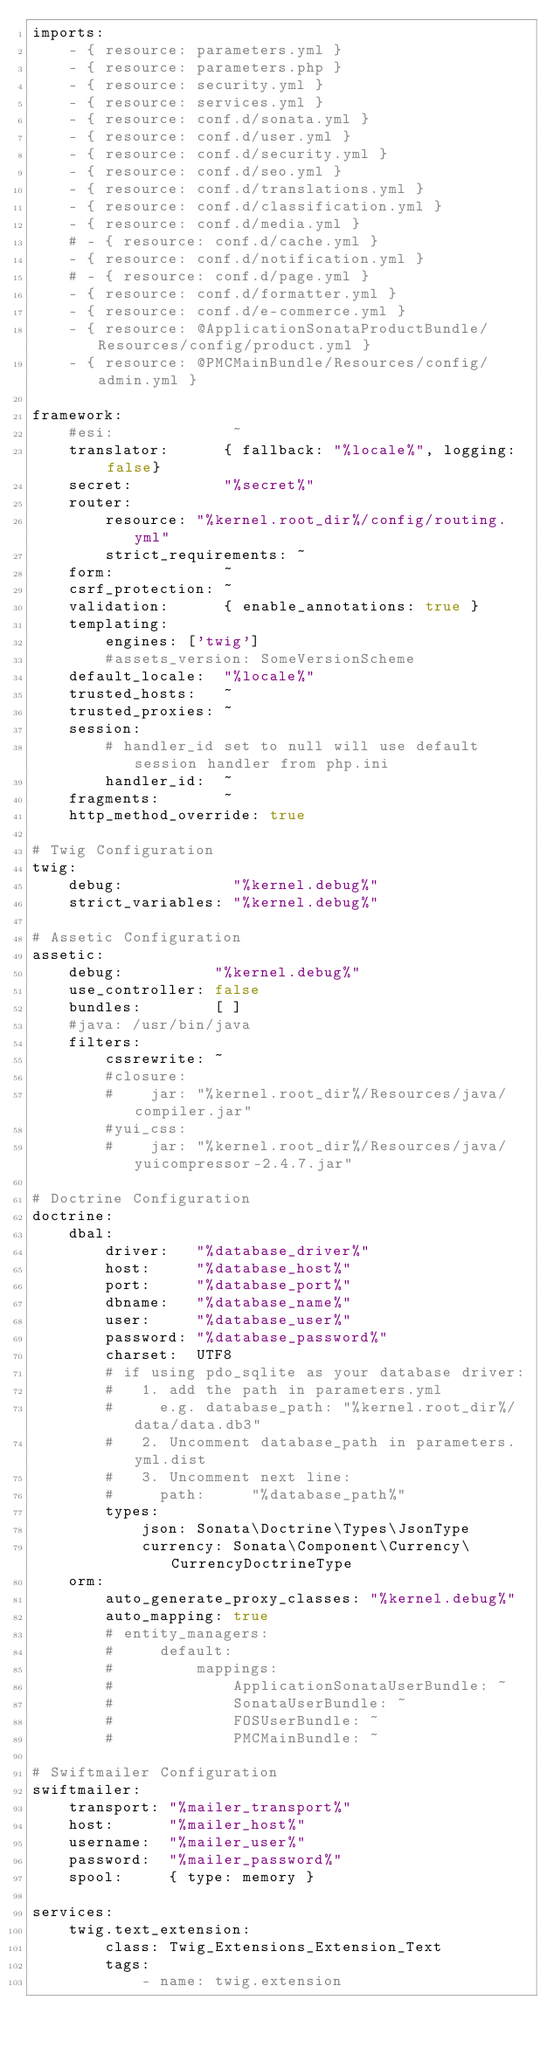Convert code to text. <code><loc_0><loc_0><loc_500><loc_500><_YAML_>imports:
    - { resource: parameters.yml }
    - { resource: parameters.php }
    - { resource: security.yml }
    - { resource: services.yml }
    - { resource: conf.d/sonata.yml }
    - { resource: conf.d/user.yml }
    - { resource: conf.d/security.yml }
    - { resource: conf.d/seo.yml }
    - { resource: conf.d/translations.yml }
    - { resource: conf.d/classification.yml }
    - { resource: conf.d/media.yml }
    # - { resource: conf.d/cache.yml }
    - { resource: conf.d/notification.yml }
    # - { resource: conf.d/page.yml }
    - { resource: conf.d/formatter.yml }
    - { resource: conf.d/e-commerce.yml }
    - { resource: @ApplicationSonataProductBundle/Resources/config/product.yml }
    - { resource: @PMCMainBundle/Resources/config/admin.yml }

framework:
    #esi:             ~
    translator:      { fallback: "%locale%", logging:  false}
    secret:          "%secret%"
    router:
        resource: "%kernel.root_dir%/config/routing.yml"
        strict_requirements: ~
    form:            ~
    csrf_protection: ~
    validation:      { enable_annotations: true }
    templating:
        engines: ['twig']
        #assets_version: SomeVersionScheme
    default_locale:  "%locale%"
    trusted_hosts:   ~
    trusted_proxies: ~
    session:
        # handler_id set to null will use default session handler from php.ini
        handler_id:  ~
    fragments:       ~
    http_method_override: true

# Twig Configuration
twig:
    debug:            "%kernel.debug%"
    strict_variables: "%kernel.debug%"

# Assetic Configuration
assetic:
    debug:          "%kernel.debug%"
    use_controller: false
    bundles:        [ ]
    #java: /usr/bin/java
    filters:
        cssrewrite: ~
        #closure:
        #    jar: "%kernel.root_dir%/Resources/java/compiler.jar"
        #yui_css:
        #    jar: "%kernel.root_dir%/Resources/java/yuicompressor-2.4.7.jar"

# Doctrine Configuration
doctrine:
    dbal:
        driver:   "%database_driver%"
        host:     "%database_host%"
        port:     "%database_port%"
        dbname:   "%database_name%"
        user:     "%database_user%"
        password: "%database_password%"
        charset:  UTF8
        # if using pdo_sqlite as your database driver:
        #   1. add the path in parameters.yml
        #     e.g. database_path: "%kernel.root_dir%/data/data.db3"
        #   2. Uncomment database_path in parameters.yml.dist
        #   3. Uncomment next line:
        #     path:     "%database_path%"
        types:
            json: Sonata\Doctrine\Types\JsonType
            currency: Sonata\Component\Currency\CurrencyDoctrineType
    orm:
        auto_generate_proxy_classes: "%kernel.debug%"
        auto_mapping: true
        # entity_managers:
        #     default:
        #         mappings:
        #             ApplicationSonataUserBundle: ~
        #             SonataUserBundle: ~
        #             FOSUserBundle: ~
        #             PMCMainBundle: ~

# Swiftmailer Configuration
swiftmailer:
    transport: "%mailer_transport%"
    host:      "%mailer_host%"
    username:  "%mailer_user%"
    password:  "%mailer_password%"
    spool:     { type: memory }

services:
    twig.text_extension:
        class: Twig_Extensions_Extension_Text
        tags:
            - name: twig.extension</code> 